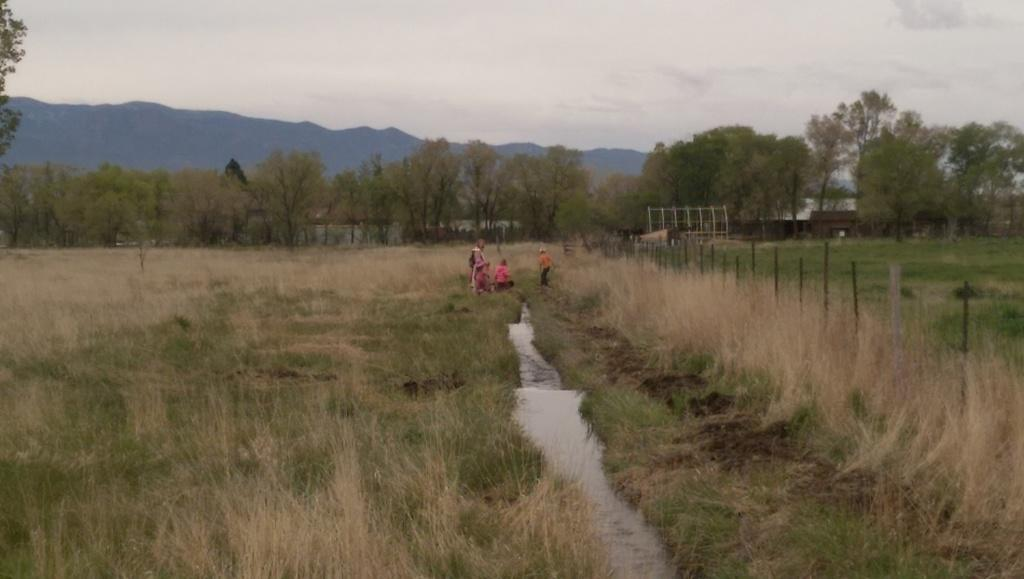What is located in the middle of the image? There are persons in the middle of the image. What can be seen in the background of the image? There are trees in the background of the image. What is at the bottom of the image? There appears to be water at the bottom of the image. What is visible at the top of the image? The sky is visible at the top of the image. What grade is the train passing through in the image? There is no train present in the image, so it is not possible to determine the grade it might be passing through. How does the growth of the trees in the background affect the persons in the image? The image does not provide information about the growth of the trees or its potential impact on the persons in the image. 